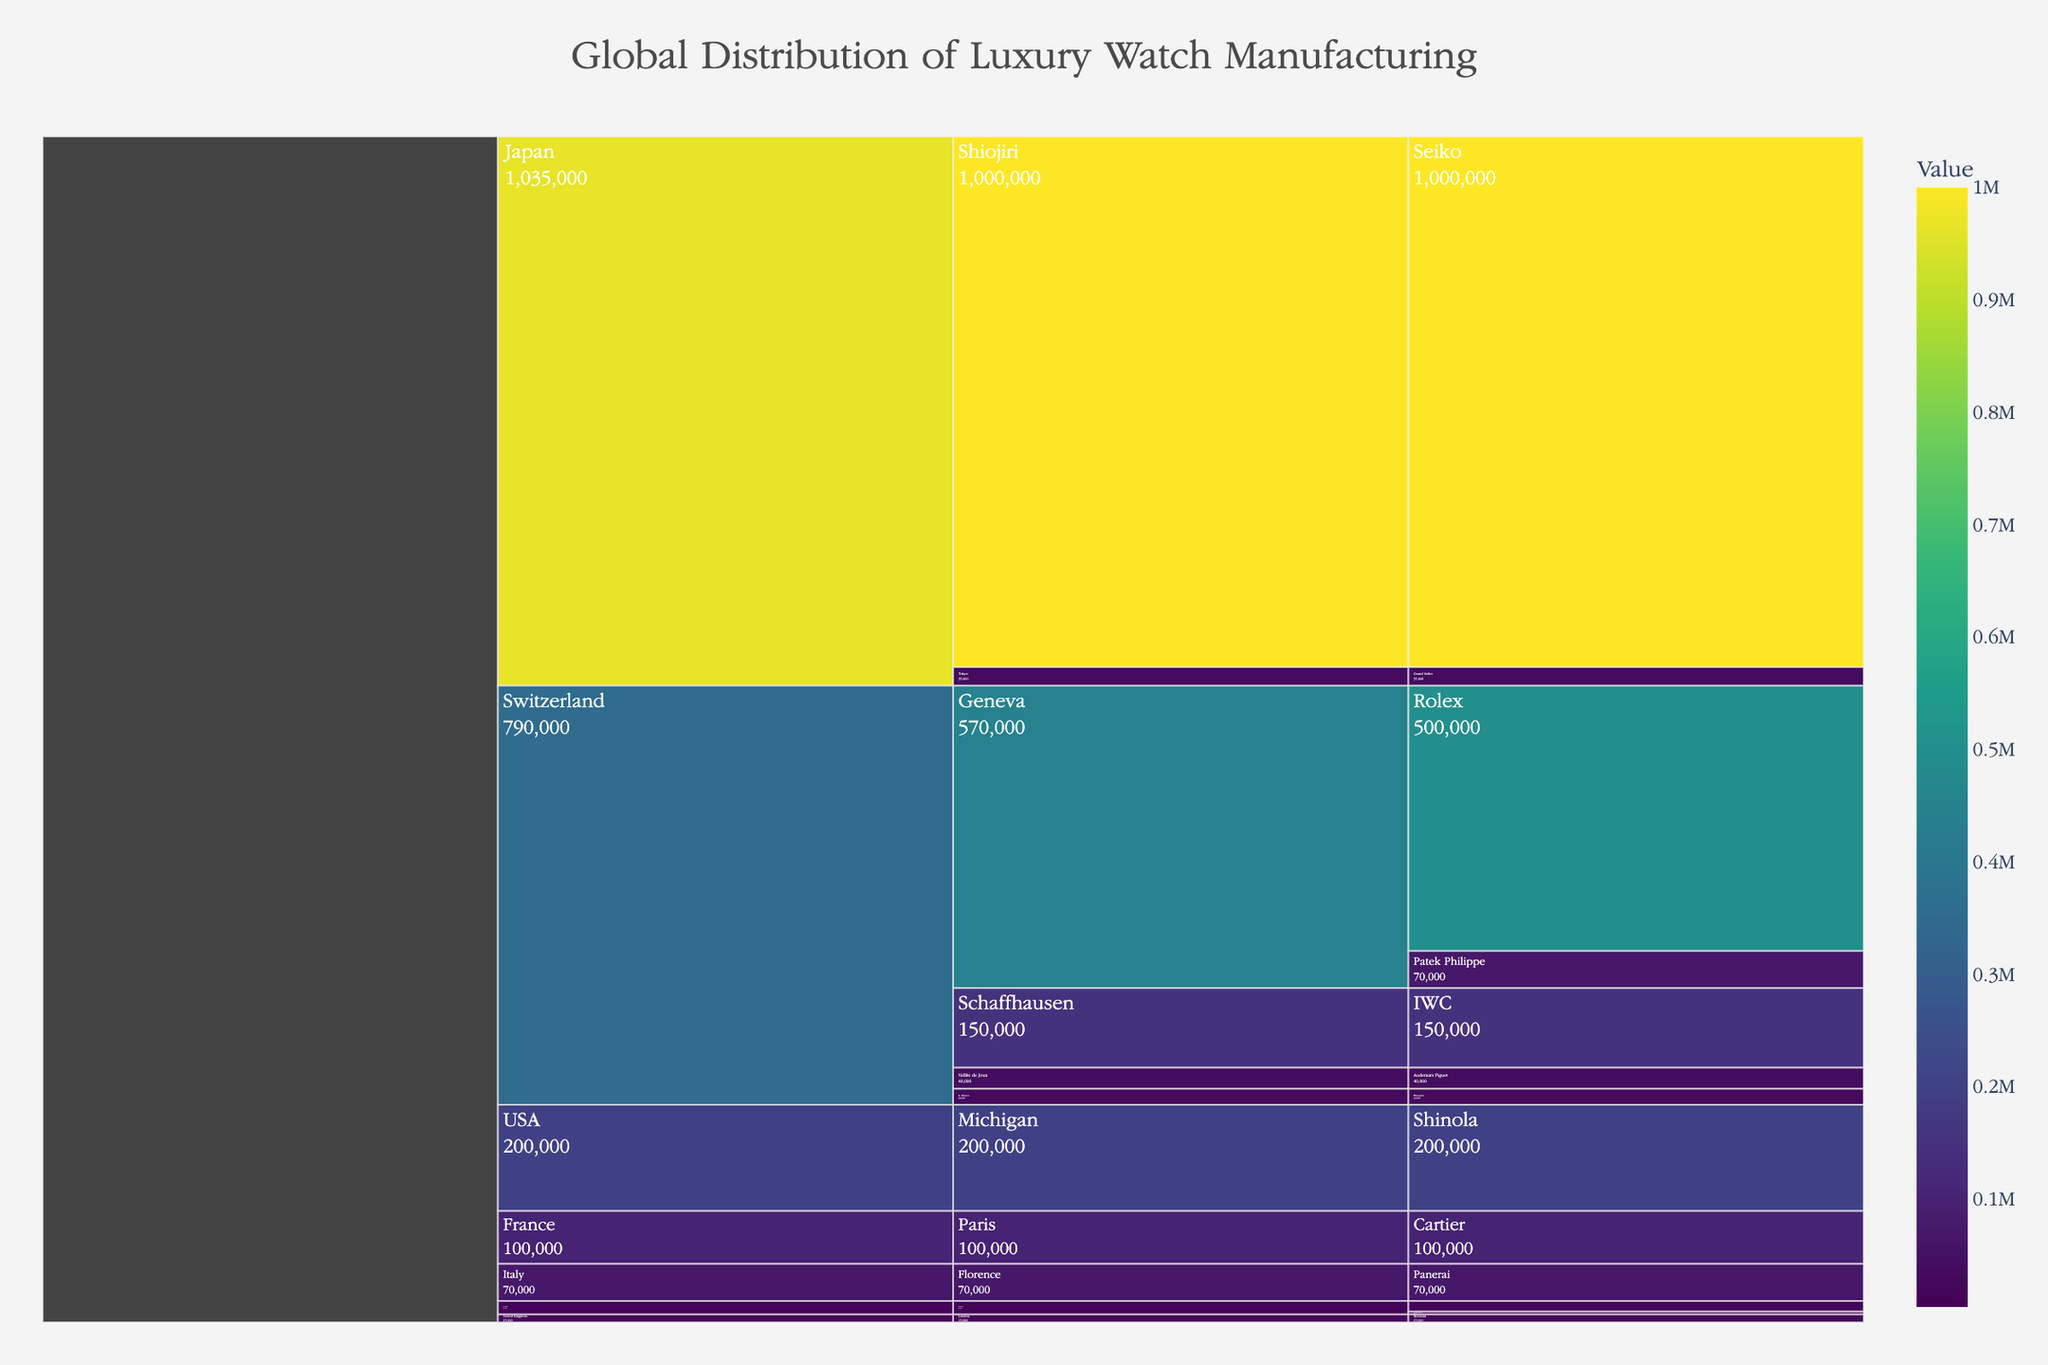What is the title of the chart? The title is located at the top center of the chart, styled with a specific font and color as per the customization details. It reads "Global Distribution of Luxury Watch Manufacturing".
Answer: Global Distribution of Luxury Watch Manufacturing Which country has the highest luxury watch production quantity? Look at the blocks representing different countries. The largest block corresponds to the country with the highest production. Here, Switzerland has the largest block, indicating it produces the most luxury watches.
Answer: Switzerland How many luxury watch brands are present in Japan according to the chart? By examining the icicle chart, count the number of branches under Japan. Japan has two branches, corresponding to "Seiko" and "Grand Seiko".
Answer: 2 What is the total luxury watch production in Germany? Sum the productions of all brands listed under Germany. A. Lange & Söhne (5,000) + Nomos Glashütte (20,000) = 25,000.
Answer: 25,000 Compare the production of Rolex and Seiko. Which one has higher production, and by how much? Locate the brands Rolex and Seiko on the chart. Rolex has 500,000 and Seiko has 1,000,000. Subtract Rolex's production from Seiko's to find the difference: 1,000,000 - 500,000 = 500,000.
Answer: Seiko, by 500,000 What regions within Switzerland are shown in the chart? Check the branches under the Switzerland block, which represent different regions. The regions are Geneva, Vallée de Joux, Schaffhausen, and Le Brassus.
Answer: Geneva, Vallée de Joux, Schaffhausen, Le Brassus Which brand in Switzerland's Vallée de Joux region has its production listed, and what is the value? Find the Swiss branch for Vallée de Joux, and then check the brand within this region. The brand is Audemars Piguet, with a production of 40,000.
Answer: Audemars Piguet, 40,000 What is the combined luxury watch production of all listed American brands? Only one American brand, Shinola, is listed. Its production is 200,000. The combined total, therefore, is 200,000.
Answer: 200,000 Which country has the smallest luxury watch production listed, and what is the value? Identify the smallest blocks representing countries. Germany has a total production of 25,000, which is smaller than all the other listed countries.
Answer: Germany, 25,000 What is the average production among the listed brands in Switzerland? Sum the production of all Swiss brands and divide by the number of brands. Sum = 500,000 (Rolex) + 70,000 (Patek Philippe) + 40,000 (Audemars Piguet) + 150,000 (IWC) + 30,000 (Blancpain) = 790,000. Number of brands = 5. Average = 790,000 / 5 = 158,000.
Answer: 158,000 